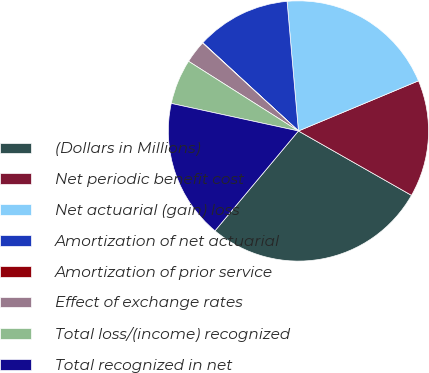<chart> <loc_0><loc_0><loc_500><loc_500><pie_chart><fcel>(Dollars in Millions)<fcel>Net periodic benefit cost<fcel>Net actuarial (gain) loss<fcel>Amortization of net actuarial<fcel>Amortization of prior service<fcel>Effect of exchange rates<fcel>Total loss/(income) recognized<fcel>Total recognized in net<nl><fcel>27.84%<fcel>14.53%<fcel>20.09%<fcel>11.75%<fcel>0.04%<fcel>2.82%<fcel>5.6%<fcel>17.31%<nl></chart> 